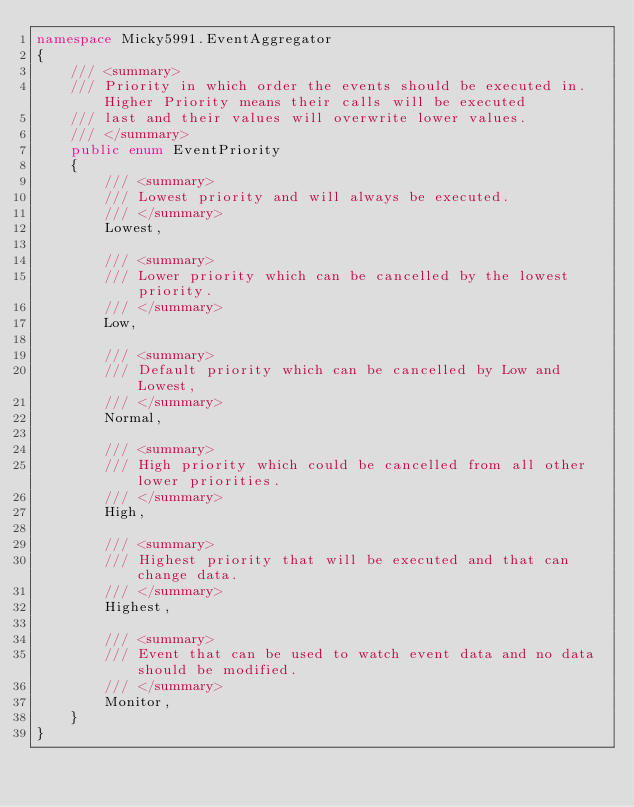<code> <loc_0><loc_0><loc_500><loc_500><_C#_>namespace Micky5991.EventAggregator
{
    /// <summary>
    /// Priority in which order the events should be executed in. Higher Priority means their calls will be executed
    /// last and their values will overwrite lower values.
    /// </summary>
    public enum EventPriority
    {
        /// <summary>
        /// Lowest priority and will always be executed.
        /// </summary>
        Lowest,

        /// <summary>
        /// Lower priority which can be cancelled by the lowest priority.
        /// </summary>
        Low,

        /// <summary>
        /// Default priority which can be cancelled by Low and Lowest,
        /// </summary>
        Normal,

        /// <summary>
        /// High priority which could be cancelled from all other lower priorities.
        /// </summary>
        High,

        /// <summary>
        /// Highest priority that will be executed and that can change data.
        /// </summary>
        Highest,

        /// <summary>
        /// Event that can be used to watch event data and no data should be modified.
        /// </summary>
        Monitor,
    }
}
</code> 